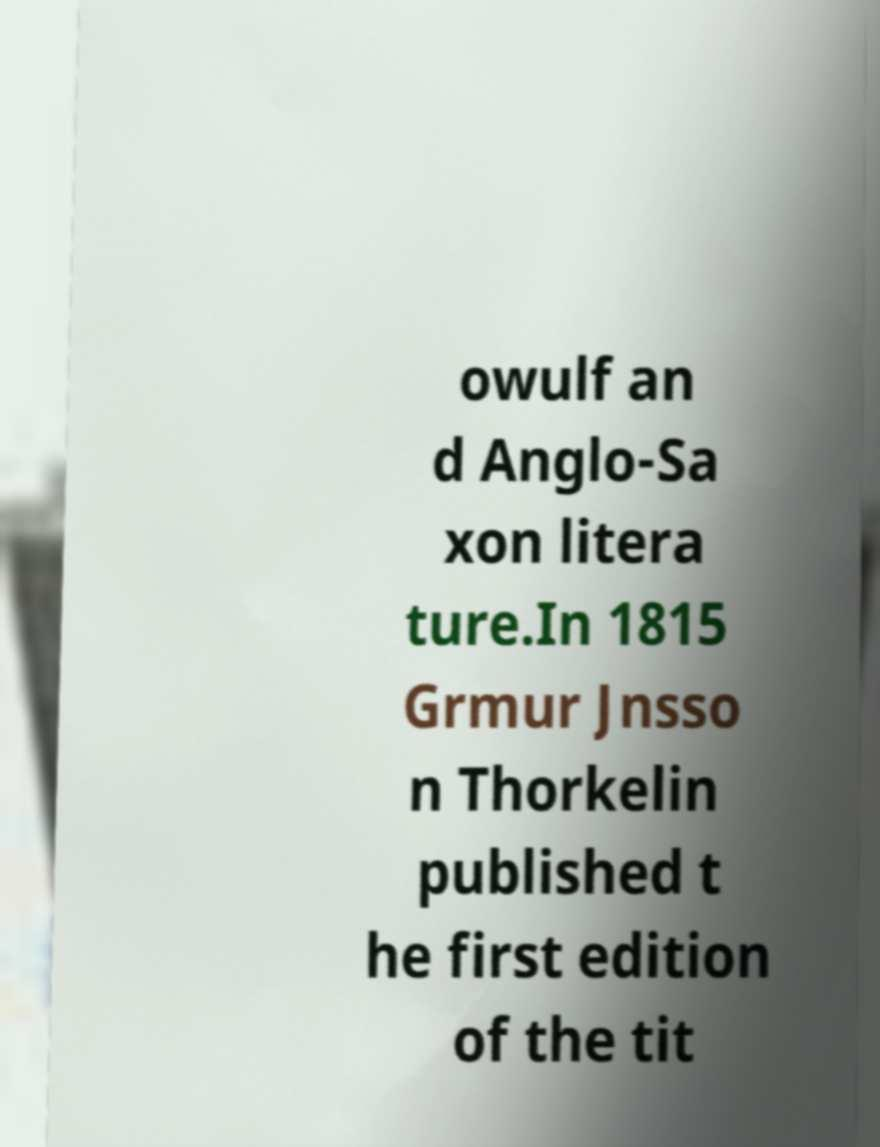Can you accurately transcribe the text from the provided image for me? owulf an d Anglo-Sa xon litera ture.In 1815 Grmur Jnsso n Thorkelin published t he first edition of the tit 